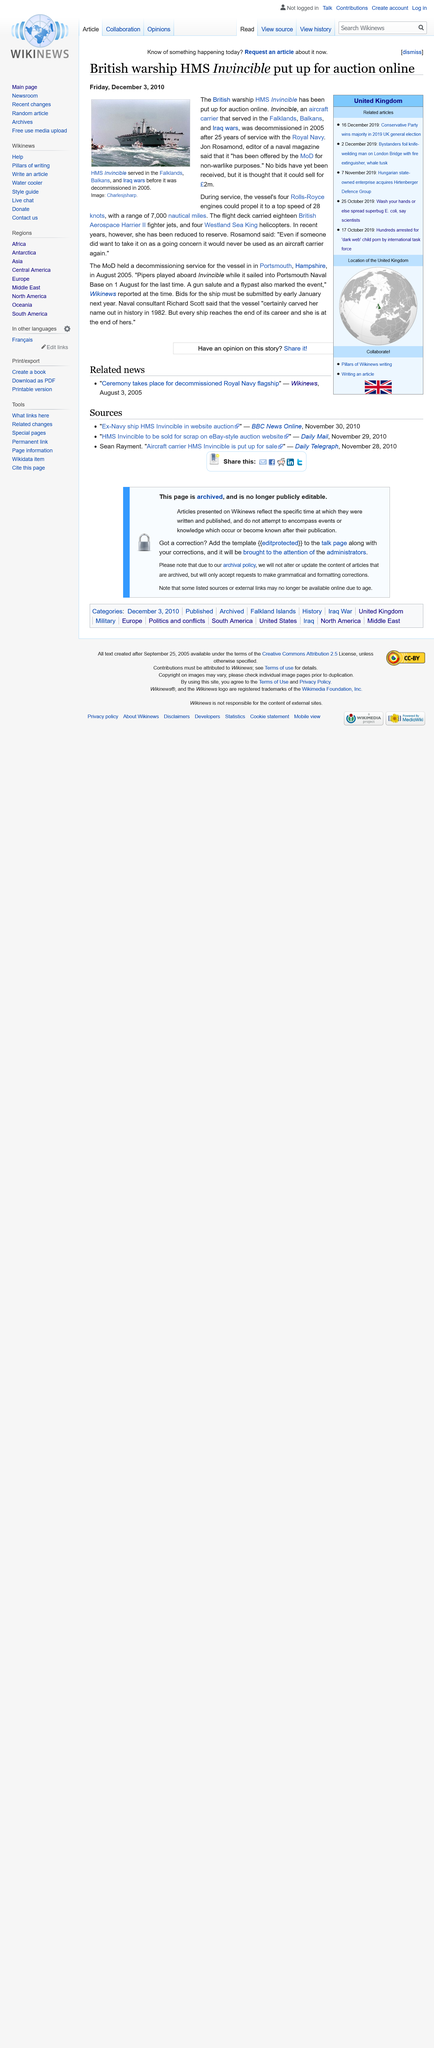Give some essential details in this illustration. The decommissioning service was held in August 2005. The ship known as the Invincible served in the Falklands, Balkans, and Iraq wars. The top speed of the Invincible was 28 knots. 